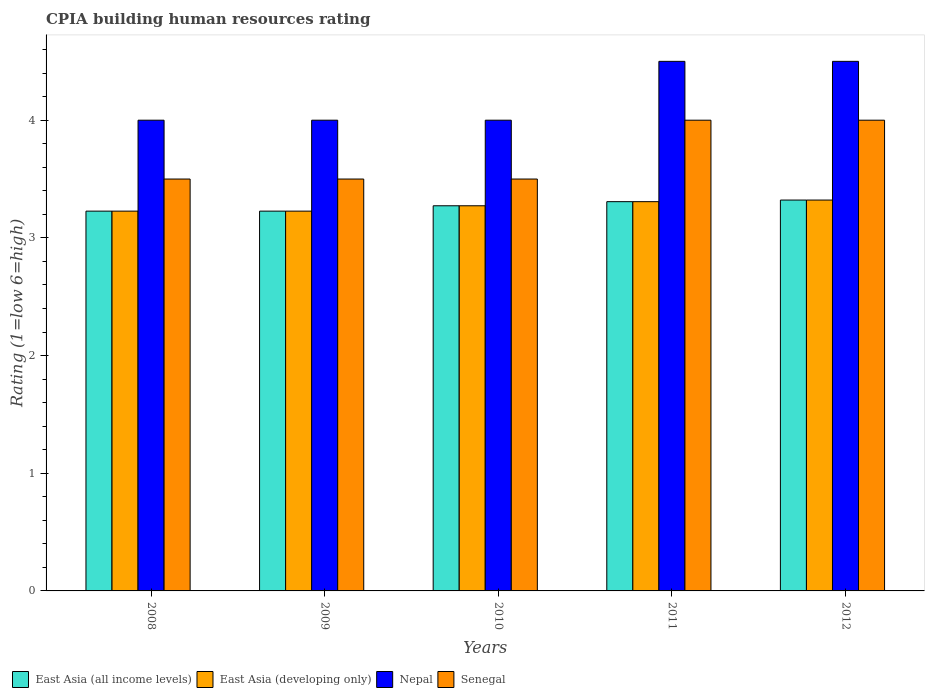How many different coloured bars are there?
Ensure brevity in your answer.  4. In how many cases, is the number of bars for a given year not equal to the number of legend labels?
Your answer should be compact. 0. What is the CPIA rating in East Asia (developing only) in 2010?
Your answer should be very brief. 3.27. Across all years, what is the minimum CPIA rating in East Asia (all income levels)?
Offer a terse response. 3.23. In which year was the CPIA rating in Nepal minimum?
Your answer should be compact. 2008. What is the difference between the CPIA rating in Nepal in 2008 and that in 2009?
Give a very brief answer. 0. What is the difference between the CPIA rating in Nepal in 2008 and the CPIA rating in East Asia (all income levels) in 2010?
Your answer should be compact. 0.73. What is the average CPIA rating in East Asia (all income levels) per year?
Offer a terse response. 3.27. What is the difference between the highest and the lowest CPIA rating in Nepal?
Offer a very short reply. 0.5. In how many years, is the CPIA rating in Nepal greater than the average CPIA rating in Nepal taken over all years?
Offer a very short reply. 2. Is the sum of the CPIA rating in East Asia (all income levels) in 2008 and 2010 greater than the maximum CPIA rating in Nepal across all years?
Offer a terse response. Yes. What does the 4th bar from the left in 2011 represents?
Your response must be concise. Senegal. What does the 1st bar from the right in 2012 represents?
Provide a succinct answer. Senegal. Is it the case that in every year, the sum of the CPIA rating in East Asia (all income levels) and CPIA rating in Senegal is greater than the CPIA rating in Nepal?
Provide a short and direct response. Yes. Are all the bars in the graph horizontal?
Offer a terse response. No. How many years are there in the graph?
Ensure brevity in your answer.  5. Does the graph contain grids?
Your response must be concise. No. How many legend labels are there?
Your answer should be compact. 4. What is the title of the graph?
Your response must be concise. CPIA building human resources rating. Does "Suriname" appear as one of the legend labels in the graph?
Your response must be concise. No. What is the Rating (1=low 6=high) of East Asia (all income levels) in 2008?
Keep it short and to the point. 3.23. What is the Rating (1=low 6=high) of East Asia (developing only) in 2008?
Make the answer very short. 3.23. What is the Rating (1=low 6=high) in Nepal in 2008?
Make the answer very short. 4. What is the Rating (1=low 6=high) of East Asia (all income levels) in 2009?
Your answer should be very brief. 3.23. What is the Rating (1=low 6=high) of East Asia (developing only) in 2009?
Give a very brief answer. 3.23. What is the Rating (1=low 6=high) of Nepal in 2009?
Offer a terse response. 4. What is the Rating (1=low 6=high) of East Asia (all income levels) in 2010?
Make the answer very short. 3.27. What is the Rating (1=low 6=high) in East Asia (developing only) in 2010?
Your answer should be compact. 3.27. What is the Rating (1=low 6=high) of East Asia (all income levels) in 2011?
Provide a short and direct response. 3.31. What is the Rating (1=low 6=high) of East Asia (developing only) in 2011?
Your answer should be very brief. 3.31. What is the Rating (1=low 6=high) in Nepal in 2011?
Keep it short and to the point. 4.5. What is the Rating (1=low 6=high) of East Asia (all income levels) in 2012?
Your answer should be very brief. 3.32. What is the Rating (1=low 6=high) of East Asia (developing only) in 2012?
Offer a very short reply. 3.32. What is the Rating (1=low 6=high) in Nepal in 2012?
Provide a succinct answer. 4.5. Across all years, what is the maximum Rating (1=low 6=high) of East Asia (all income levels)?
Keep it short and to the point. 3.32. Across all years, what is the maximum Rating (1=low 6=high) in East Asia (developing only)?
Offer a terse response. 3.32. Across all years, what is the maximum Rating (1=low 6=high) in Nepal?
Ensure brevity in your answer.  4.5. Across all years, what is the minimum Rating (1=low 6=high) in East Asia (all income levels)?
Provide a succinct answer. 3.23. Across all years, what is the minimum Rating (1=low 6=high) in East Asia (developing only)?
Provide a short and direct response. 3.23. Across all years, what is the minimum Rating (1=low 6=high) of Senegal?
Your answer should be very brief. 3.5. What is the total Rating (1=low 6=high) in East Asia (all income levels) in the graph?
Provide a succinct answer. 16.36. What is the total Rating (1=low 6=high) in East Asia (developing only) in the graph?
Provide a succinct answer. 16.36. What is the total Rating (1=low 6=high) of Senegal in the graph?
Your answer should be compact. 18.5. What is the difference between the Rating (1=low 6=high) in East Asia (all income levels) in 2008 and that in 2009?
Ensure brevity in your answer.  0. What is the difference between the Rating (1=low 6=high) in Nepal in 2008 and that in 2009?
Make the answer very short. 0. What is the difference between the Rating (1=low 6=high) in East Asia (all income levels) in 2008 and that in 2010?
Make the answer very short. -0.05. What is the difference between the Rating (1=low 6=high) of East Asia (developing only) in 2008 and that in 2010?
Offer a terse response. -0.05. What is the difference between the Rating (1=low 6=high) in Nepal in 2008 and that in 2010?
Give a very brief answer. 0. What is the difference between the Rating (1=low 6=high) in Senegal in 2008 and that in 2010?
Provide a short and direct response. 0. What is the difference between the Rating (1=low 6=high) of East Asia (all income levels) in 2008 and that in 2011?
Give a very brief answer. -0.08. What is the difference between the Rating (1=low 6=high) in East Asia (developing only) in 2008 and that in 2011?
Your response must be concise. -0.08. What is the difference between the Rating (1=low 6=high) of East Asia (all income levels) in 2008 and that in 2012?
Provide a short and direct response. -0.09. What is the difference between the Rating (1=low 6=high) of East Asia (developing only) in 2008 and that in 2012?
Keep it short and to the point. -0.09. What is the difference between the Rating (1=low 6=high) of Senegal in 2008 and that in 2012?
Your answer should be very brief. -0.5. What is the difference between the Rating (1=low 6=high) in East Asia (all income levels) in 2009 and that in 2010?
Your answer should be compact. -0.05. What is the difference between the Rating (1=low 6=high) in East Asia (developing only) in 2009 and that in 2010?
Make the answer very short. -0.05. What is the difference between the Rating (1=low 6=high) of Senegal in 2009 and that in 2010?
Keep it short and to the point. 0. What is the difference between the Rating (1=low 6=high) of East Asia (all income levels) in 2009 and that in 2011?
Offer a terse response. -0.08. What is the difference between the Rating (1=low 6=high) in East Asia (developing only) in 2009 and that in 2011?
Make the answer very short. -0.08. What is the difference between the Rating (1=low 6=high) of East Asia (all income levels) in 2009 and that in 2012?
Your answer should be very brief. -0.09. What is the difference between the Rating (1=low 6=high) in East Asia (developing only) in 2009 and that in 2012?
Ensure brevity in your answer.  -0.09. What is the difference between the Rating (1=low 6=high) of Senegal in 2009 and that in 2012?
Offer a terse response. -0.5. What is the difference between the Rating (1=low 6=high) in East Asia (all income levels) in 2010 and that in 2011?
Keep it short and to the point. -0.04. What is the difference between the Rating (1=low 6=high) of East Asia (developing only) in 2010 and that in 2011?
Your answer should be very brief. -0.04. What is the difference between the Rating (1=low 6=high) of Nepal in 2010 and that in 2011?
Offer a very short reply. -0.5. What is the difference between the Rating (1=low 6=high) in Senegal in 2010 and that in 2011?
Offer a very short reply. -0.5. What is the difference between the Rating (1=low 6=high) in East Asia (all income levels) in 2010 and that in 2012?
Offer a terse response. -0.05. What is the difference between the Rating (1=low 6=high) of East Asia (developing only) in 2010 and that in 2012?
Your response must be concise. -0.05. What is the difference between the Rating (1=low 6=high) of Nepal in 2010 and that in 2012?
Your answer should be compact. -0.5. What is the difference between the Rating (1=low 6=high) of East Asia (all income levels) in 2011 and that in 2012?
Your answer should be compact. -0.01. What is the difference between the Rating (1=low 6=high) of East Asia (developing only) in 2011 and that in 2012?
Your response must be concise. -0.01. What is the difference between the Rating (1=low 6=high) in Senegal in 2011 and that in 2012?
Your response must be concise. 0. What is the difference between the Rating (1=low 6=high) of East Asia (all income levels) in 2008 and the Rating (1=low 6=high) of Nepal in 2009?
Your answer should be very brief. -0.77. What is the difference between the Rating (1=low 6=high) of East Asia (all income levels) in 2008 and the Rating (1=low 6=high) of Senegal in 2009?
Your response must be concise. -0.27. What is the difference between the Rating (1=low 6=high) of East Asia (developing only) in 2008 and the Rating (1=low 6=high) of Nepal in 2009?
Give a very brief answer. -0.77. What is the difference between the Rating (1=low 6=high) in East Asia (developing only) in 2008 and the Rating (1=low 6=high) in Senegal in 2009?
Offer a terse response. -0.27. What is the difference between the Rating (1=low 6=high) in East Asia (all income levels) in 2008 and the Rating (1=low 6=high) in East Asia (developing only) in 2010?
Your answer should be compact. -0.05. What is the difference between the Rating (1=low 6=high) of East Asia (all income levels) in 2008 and the Rating (1=low 6=high) of Nepal in 2010?
Offer a very short reply. -0.77. What is the difference between the Rating (1=low 6=high) of East Asia (all income levels) in 2008 and the Rating (1=low 6=high) of Senegal in 2010?
Make the answer very short. -0.27. What is the difference between the Rating (1=low 6=high) in East Asia (developing only) in 2008 and the Rating (1=low 6=high) in Nepal in 2010?
Your response must be concise. -0.77. What is the difference between the Rating (1=low 6=high) of East Asia (developing only) in 2008 and the Rating (1=low 6=high) of Senegal in 2010?
Ensure brevity in your answer.  -0.27. What is the difference between the Rating (1=low 6=high) of Nepal in 2008 and the Rating (1=low 6=high) of Senegal in 2010?
Your answer should be compact. 0.5. What is the difference between the Rating (1=low 6=high) in East Asia (all income levels) in 2008 and the Rating (1=low 6=high) in East Asia (developing only) in 2011?
Make the answer very short. -0.08. What is the difference between the Rating (1=low 6=high) in East Asia (all income levels) in 2008 and the Rating (1=low 6=high) in Nepal in 2011?
Your answer should be very brief. -1.27. What is the difference between the Rating (1=low 6=high) in East Asia (all income levels) in 2008 and the Rating (1=low 6=high) in Senegal in 2011?
Make the answer very short. -0.77. What is the difference between the Rating (1=low 6=high) of East Asia (developing only) in 2008 and the Rating (1=low 6=high) of Nepal in 2011?
Your answer should be compact. -1.27. What is the difference between the Rating (1=low 6=high) in East Asia (developing only) in 2008 and the Rating (1=low 6=high) in Senegal in 2011?
Your answer should be compact. -0.77. What is the difference between the Rating (1=low 6=high) in East Asia (all income levels) in 2008 and the Rating (1=low 6=high) in East Asia (developing only) in 2012?
Offer a very short reply. -0.09. What is the difference between the Rating (1=low 6=high) of East Asia (all income levels) in 2008 and the Rating (1=low 6=high) of Nepal in 2012?
Provide a succinct answer. -1.27. What is the difference between the Rating (1=low 6=high) in East Asia (all income levels) in 2008 and the Rating (1=low 6=high) in Senegal in 2012?
Provide a short and direct response. -0.77. What is the difference between the Rating (1=low 6=high) in East Asia (developing only) in 2008 and the Rating (1=low 6=high) in Nepal in 2012?
Give a very brief answer. -1.27. What is the difference between the Rating (1=low 6=high) of East Asia (developing only) in 2008 and the Rating (1=low 6=high) of Senegal in 2012?
Ensure brevity in your answer.  -0.77. What is the difference between the Rating (1=low 6=high) in Nepal in 2008 and the Rating (1=low 6=high) in Senegal in 2012?
Keep it short and to the point. 0. What is the difference between the Rating (1=low 6=high) of East Asia (all income levels) in 2009 and the Rating (1=low 6=high) of East Asia (developing only) in 2010?
Provide a short and direct response. -0.05. What is the difference between the Rating (1=low 6=high) of East Asia (all income levels) in 2009 and the Rating (1=low 6=high) of Nepal in 2010?
Your answer should be compact. -0.77. What is the difference between the Rating (1=low 6=high) in East Asia (all income levels) in 2009 and the Rating (1=low 6=high) in Senegal in 2010?
Make the answer very short. -0.27. What is the difference between the Rating (1=low 6=high) of East Asia (developing only) in 2009 and the Rating (1=low 6=high) of Nepal in 2010?
Your answer should be compact. -0.77. What is the difference between the Rating (1=low 6=high) of East Asia (developing only) in 2009 and the Rating (1=low 6=high) of Senegal in 2010?
Your response must be concise. -0.27. What is the difference between the Rating (1=low 6=high) of East Asia (all income levels) in 2009 and the Rating (1=low 6=high) of East Asia (developing only) in 2011?
Provide a succinct answer. -0.08. What is the difference between the Rating (1=low 6=high) of East Asia (all income levels) in 2009 and the Rating (1=low 6=high) of Nepal in 2011?
Offer a very short reply. -1.27. What is the difference between the Rating (1=low 6=high) of East Asia (all income levels) in 2009 and the Rating (1=low 6=high) of Senegal in 2011?
Ensure brevity in your answer.  -0.77. What is the difference between the Rating (1=low 6=high) in East Asia (developing only) in 2009 and the Rating (1=low 6=high) in Nepal in 2011?
Keep it short and to the point. -1.27. What is the difference between the Rating (1=low 6=high) of East Asia (developing only) in 2009 and the Rating (1=low 6=high) of Senegal in 2011?
Your response must be concise. -0.77. What is the difference between the Rating (1=low 6=high) of East Asia (all income levels) in 2009 and the Rating (1=low 6=high) of East Asia (developing only) in 2012?
Offer a very short reply. -0.09. What is the difference between the Rating (1=low 6=high) in East Asia (all income levels) in 2009 and the Rating (1=low 6=high) in Nepal in 2012?
Keep it short and to the point. -1.27. What is the difference between the Rating (1=low 6=high) of East Asia (all income levels) in 2009 and the Rating (1=low 6=high) of Senegal in 2012?
Make the answer very short. -0.77. What is the difference between the Rating (1=low 6=high) of East Asia (developing only) in 2009 and the Rating (1=low 6=high) of Nepal in 2012?
Give a very brief answer. -1.27. What is the difference between the Rating (1=low 6=high) in East Asia (developing only) in 2009 and the Rating (1=low 6=high) in Senegal in 2012?
Provide a succinct answer. -0.77. What is the difference between the Rating (1=low 6=high) in Nepal in 2009 and the Rating (1=low 6=high) in Senegal in 2012?
Provide a succinct answer. 0. What is the difference between the Rating (1=low 6=high) of East Asia (all income levels) in 2010 and the Rating (1=low 6=high) of East Asia (developing only) in 2011?
Your response must be concise. -0.04. What is the difference between the Rating (1=low 6=high) in East Asia (all income levels) in 2010 and the Rating (1=low 6=high) in Nepal in 2011?
Your response must be concise. -1.23. What is the difference between the Rating (1=low 6=high) in East Asia (all income levels) in 2010 and the Rating (1=low 6=high) in Senegal in 2011?
Your answer should be compact. -0.73. What is the difference between the Rating (1=low 6=high) in East Asia (developing only) in 2010 and the Rating (1=low 6=high) in Nepal in 2011?
Make the answer very short. -1.23. What is the difference between the Rating (1=low 6=high) in East Asia (developing only) in 2010 and the Rating (1=low 6=high) in Senegal in 2011?
Make the answer very short. -0.73. What is the difference between the Rating (1=low 6=high) of East Asia (all income levels) in 2010 and the Rating (1=low 6=high) of East Asia (developing only) in 2012?
Offer a terse response. -0.05. What is the difference between the Rating (1=low 6=high) in East Asia (all income levels) in 2010 and the Rating (1=low 6=high) in Nepal in 2012?
Give a very brief answer. -1.23. What is the difference between the Rating (1=low 6=high) in East Asia (all income levels) in 2010 and the Rating (1=low 6=high) in Senegal in 2012?
Offer a terse response. -0.73. What is the difference between the Rating (1=low 6=high) in East Asia (developing only) in 2010 and the Rating (1=low 6=high) in Nepal in 2012?
Ensure brevity in your answer.  -1.23. What is the difference between the Rating (1=low 6=high) of East Asia (developing only) in 2010 and the Rating (1=low 6=high) of Senegal in 2012?
Your answer should be compact. -0.73. What is the difference between the Rating (1=low 6=high) of Nepal in 2010 and the Rating (1=low 6=high) of Senegal in 2012?
Make the answer very short. 0. What is the difference between the Rating (1=low 6=high) of East Asia (all income levels) in 2011 and the Rating (1=low 6=high) of East Asia (developing only) in 2012?
Your response must be concise. -0.01. What is the difference between the Rating (1=low 6=high) of East Asia (all income levels) in 2011 and the Rating (1=low 6=high) of Nepal in 2012?
Your answer should be compact. -1.19. What is the difference between the Rating (1=low 6=high) of East Asia (all income levels) in 2011 and the Rating (1=low 6=high) of Senegal in 2012?
Your answer should be compact. -0.69. What is the difference between the Rating (1=low 6=high) of East Asia (developing only) in 2011 and the Rating (1=low 6=high) of Nepal in 2012?
Ensure brevity in your answer.  -1.19. What is the difference between the Rating (1=low 6=high) of East Asia (developing only) in 2011 and the Rating (1=low 6=high) of Senegal in 2012?
Ensure brevity in your answer.  -0.69. What is the difference between the Rating (1=low 6=high) in Nepal in 2011 and the Rating (1=low 6=high) in Senegal in 2012?
Provide a short and direct response. 0.5. What is the average Rating (1=low 6=high) of East Asia (all income levels) per year?
Provide a succinct answer. 3.27. What is the average Rating (1=low 6=high) in East Asia (developing only) per year?
Provide a succinct answer. 3.27. What is the average Rating (1=low 6=high) in Nepal per year?
Your response must be concise. 4.2. What is the average Rating (1=low 6=high) of Senegal per year?
Make the answer very short. 3.7. In the year 2008, what is the difference between the Rating (1=low 6=high) in East Asia (all income levels) and Rating (1=low 6=high) in East Asia (developing only)?
Provide a succinct answer. 0. In the year 2008, what is the difference between the Rating (1=low 6=high) of East Asia (all income levels) and Rating (1=low 6=high) of Nepal?
Offer a very short reply. -0.77. In the year 2008, what is the difference between the Rating (1=low 6=high) of East Asia (all income levels) and Rating (1=low 6=high) of Senegal?
Provide a succinct answer. -0.27. In the year 2008, what is the difference between the Rating (1=low 6=high) in East Asia (developing only) and Rating (1=low 6=high) in Nepal?
Offer a terse response. -0.77. In the year 2008, what is the difference between the Rating (1=low 6=high) in East Asia (developing only) and Rating (1=low 6=high) in Senegal?
Your answer should be compact. -0.27. In the year 2008, what is the difference between the Rating (1=low 6=high) of Nepal and Rating (1=low 6=high) of Senegal?
Provide a succinct answer. 0.5. In the year 2009, what is the difference between the Rating (1=low 6=high) in East Asia (all income levels) and Rating (1=low 6=high) in East Asia (developing only)?
Provide a short and direct response. 0. In the year 2009, what is the difference between the Rating (1=low 6=high) of East Asia (all income levels) and Rating (1=low 6=high) of Nepal?
Ensure brevity in your answer.  -0.77. In the year 2009, what is the difference between the Rating (1=low 6=high) of East Asia (all income levels) and Rating (1=low 6=high) of Senegal?
Ensure brevity in your answer.  -0.27. In the year 2009, what is the difference between the Rating (1=low 6=high) of East Asia (developing only) and Rating (1=low 6=high) of Nepal?
Provide a short and direct response. -0.77. In the year 2009, what is the difference between the Rating (1=low 6=high) in East Asia (developing only) and Rating (1=low 6=high) in Senegal?
Give a very brief answer. -0.27. In the year 2009, what is the difference between the Rating (1=low 6=high) of Nepal and Rating (1=low 6=high) of Senegal?
Offer a very short reply. 0.5. In the year 2010, what is the difference between the Rating (1=low 6=high) in East Asia (all income levels) and Rating (1=low 6=high) in Nepal?
Offer a terse response. -0.73. In the year 2010, what is the difference between the Rating (1=low 6=high) of East Asia (all income levels) and Rating (1=low 6=high) of Senegal?
Provide a short and direct response. -0.23. In the year 2010, what is the difference between the Rating (1=low 6=high) in East Asia (developing only) and Rating (1=low 6=high) in Nepal?
Your answer should be very brief. -0.73. In the year 2010, what is the difference between the Rating (1=low 6=high) in East Asia (developing only) and Rating (1=low 6=high) in Senegal?
Your answer should be very brief. -0.23. In the year 2011, what is the difference between the Rating (1=low 6=high) of East Asia (all income levels) and Rating (1=low 6=high) of Nepal?
Keep it short and to the point. -1.19. In the year 2011, what is the difference between the Rating (1=low 6=high) in East Asia (all income levels) and Rating (1=low 6=high) in Senegal?
Provide a short and direct response. -0.69. In the year 2011, what is the difference between the Rating (1=low 6=high) in East Asia (developing only) and Rating (1=low 6=high) in Nepal?
Keep it short and to the point. -1.19. In the year 2011, what is the difference between the Rating (1=low 6=high) in East Asia (developing only) and Rating (1=low 6=high) in Senegal?
Provide a succinct answer. -0.69. In the year 2012, what is the difference between the Rating (1=low 6=high) of East Asia (all income levels) and Rating (1=low 6=high) of Nepal?
Give a very brief answer. -1.18. In the year 2012, what is the difference between the Rating (1=low 6=high) in East Asia (all income levels) and Rating (1=low 6=high) in Senegal?
Keep it short and to the point. -0.68. In the year 2012, what is the difference between the Rating (1=low 6=high) of East Asia (developing only) and Rating (1=low 6=high) of Nepal?
Ensure brevity in your answer.  -1.18. In the year 2012, what is the difference between the Rating (1=low 6=high) in East Asia (developing only) and Rating (1=low 6=high) in Senegal?
Provide a succinct answer. -0.68. What is the ratio of the Rating (1=low 6=high) in East Asia (developing only) in 2008 to that in 2009?
Keep it short and to the point. 1. What is the ratio of the Rating (1=low 6=high) in Senegal in 2008 to that in 2009?
Offer a very short reply. 1. What is the ratio of the Rating (1=low 6=high) of East Asia (all income levels) in 2008 to that in 2010?
Your response must be concise. 0.99. What is the ratio of the Rating (1=low 6=high) of East Asia (developing only) in 2008 to that in 2010?
Provide a succinct answer. 0.99. What is the ratio of the Rating (1=low 6=high) of Nepal in 2008 to that in 2010?
Offer a terse response. 1. What is the ratio of the Rating (1=low 6=high) in East Asia (all income levels) in 2008 to that in 2011?
Offer a terse response. 0.98. What is the ratio of the Rating (1=low 6=high) in East Asia (developing only) in 2008 to that in 2011?
Ensure brevity in your answer.  0.98. What is the ratio of the Rating (1=low 6=high) in Nepal in 2008 to that in 2011?
Keep it short and to the point. 0.89. What is the ratio of the Rating (1=low 6=high) in Senegal in 2008 to that in 2011?
Ensure brevity in your answer.  0.88. What is the ratio of the Rating (1=low 6=high) of East Asia (all income levels) in 2008 to that in 2012?
Give a very brief answer. 0.97. What is the ratio of the Rating (1=low 6=high) in East Asia (developing only) in 2008 to that in 2012?
Ensure brevity in your answer.  0.97. What is the ratio of the Rating (1=low 6=high) of Nepal in 2008 to that in 2012?
Provide a succinct answer. 0.89. What is the ratio of the Rating (1=low 6=high) of Senegal in 2008 to that in 2012?
Offer a very short reply. 0.88. What is the ratio of the Rating (1=low 6=high) of East Asia (all income levels) in 2009 to that in 2010?
Your answer should be very brief. 0.99. What is the ratio of the Rating (1=low 6=high) in East Asia (developing only) in 2009 to that in 2010?
Your answer should be compact. 0.99. What is the ratio of the Rating (1=low 6=high) in Nepal in 2009 to that in 2010?
Offer a terse response. 1. What is the ratio of the Rating (1=low 6=high) in Senegal in 2009 to that in 2010?
Provide a succinct answer. 1. What is the ratio of the Rating (1=low 6=high) in East Asia (all income levels) in 2009 to that in 2011?
Make the answer very short. 0.98. What is the ratio of the Rating (1=low 6=high) of East Asia (developing only) in 2009 to that in 2011?
Your answer should be compact. 0.98. What is the ratio of the Rating (1=low 6=high) in East Asia (all income levels) in 2009 to that in 2012?
Ensure brevity in your answer.  0.97. What is the ratio of the Rating (1=low 6=high) in East Asia (developing only) in 2009 to that in 2012?
Offer a terse response. 0.97. What is the ratio of the Rating (1=low 6=high) of Nepal in 2009 to that in 2012?
Your response must be concise. 0.89. What is the ratio of the Rating (1=low 6=high) of Nepal in 2010 to that in 2011?
Make the answer very short. 0.89. What is the ratio of the Rating (1=low 6=high) in East Asia (developing only) in 2010 to that in 2012?
Ensure brevity in your answer.  0.99. What is the ratio of the Rating (1=low 6=high) in Nepal in 2010 to that in 2012?
Offer a very short reply. 0.89. What is the ratio of the Rating (1=low 6=high) of East Asia (developing only) in 2011 to that in 2012?
Give a very brief answer. 1. What is the ratio of the Rating (1=low 6=high) in Nepal in 2011 to that in 2012?
Give a very brief answer. 1. What is the ratio of the Rating (1=low 6=high) of Senegal in 2011 to that in 2012?
Provide a short and direct response. 1. What is the difference between the highest and the second highest Rating (1=low 6=high) in East Asia (all income levels)?
Keep it short and to the point. 0.01. What is the difference between the highest and the second highest Rating (1=low 6=high) in East Asia (developing only)?
Your answer should be compact. 0.01. What is the difference between the highest and the second highest Rating (1=low 6=high) of Nepal?
Your answer should be very brief. 0. What is the difference between the highest and the lowest Rating (1=low 6=high) of East Asia (all income levels)?
Make the answer very short. 0.09. What is the difference between the highest and the lowest Rating (1=low 6=high) in East Asia (developing only)?
Your answer should be compact. 0.09. What is the difference between the highest and the lowest Rating (1=low 6=high) of Senegal?
Your answer should be very brief. 0.5. 